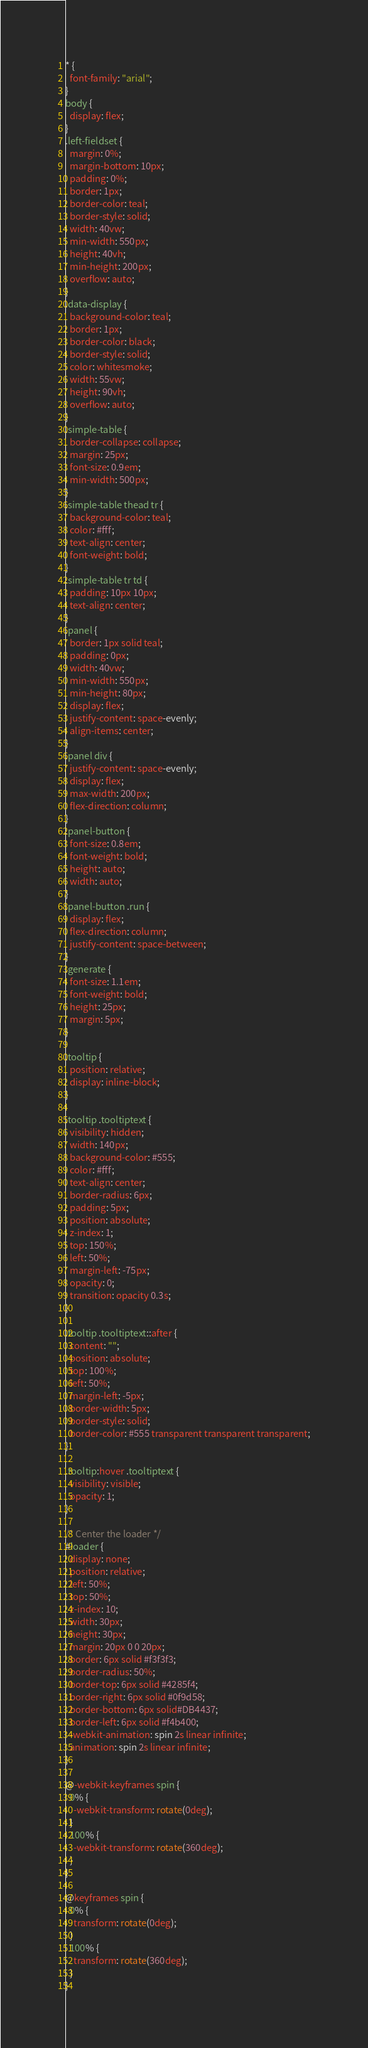<code> <loc_0><loc_0><loc_500><loc_500><_CSS_>* {
  font-family: "arial";
}
body {
  display: flex;
}
.left-fieldset {
  margin: 0%;
  margin-bottom: 10px;
  padding: 0%;
  border: 1px;
  border-color: teal;
  border-style: solid;
  width: 40vw;
  min-width: 550px;
  height: 40vh;
  min-height: 200px;
  overflow: auto;
}
.data-display {
  background-color: teal;
  border: 1px;
  border-color: black;
  border-style: solid;
  color: whitesmoke;
  width: 55vw;
  height: 90vh;
  overflow: auto;
}
.simple-table {
  border-collapse: collapse;
  margin: 25px;
  font-size: 0.9em;
  min-width: 500px;
}
.simple-table thead tr {
  background-color: teal;
  color: #fff;
  text-align: center;
  font-weight: bold;
}
.simple-table tr td {
  padding: 10px 10px;
  text-align: center;
}
.panel {
  border: 1px solid teal;
  padding: 0px;
  width: 40vw;
  min-width: 550px;
  min-height: 80px;
  display: flex;
  justify-content: space-evenly;
  align-items: center;
}
.panel div {
  justify-content: space-evenly;
  display: flex;
  max-width: 200px;
  flex-direction: column;
}
.panel-button {
  font-size: 0.8em;
  font-weight: bold;
  height: auto;
  width: auto;
}
.panel-button .run {
  display: flex;
  flex-direction: column;
  justify-content: space-between;
}
.generate {
  font-size: 1.1em;
  font-weight: bold;
  height: 25px;
  margin: 5px;
}

.tooltip {
  position: relative;
  display: inline-block;
}

.tooltip .tooltiptext {
  visibility: hidden;
  width: 140px;
  background-color: #555;
  color: #fff;
  text-align: center;
  border-radius: 6px;
  padding: 5px;
  position: absolute;
  z-index: 1;
  top: 150%;
  left: 50%;
  margin-left: -75px;
  opacity: 0;
  transition: opacity 0.3s;
}

.tooltip .tooltiptext::after {
  content: "";
  position: absolute;
  top: 100%;
  left: 50%;
  margin-left: -5px;
  border-width: 5px;
  border-style: solid;
  border-color: #555 transparent transparent transparent;
}

.tooltip:hover .tooltiptext {
  visibility: visible;
  opacity: 1;
}

/* Center the loader */
#loader {
  display: none;
  position: relative;
  left: 50%;
  top: 50%;
  z-index: 10;
  width: 30px;
  height: 30px;
  margin: 20px 0 0 20px;
  border: 6px solid #f3f3f3;
  border-radius: 50%;
  border-top: 6px solid #4285f4;
  border-right: 6px solid #0f9d58;
  border-bottom: 6px solid#DB4437;
  border-left: 6px solid #f4b400;
  -webkit-animation: spin 2s linear infinite;
  animation: spin 2s linear infinite;
}

@-webkit-keyframes spin {
  0% {
    -webkit-transform: rotate(0deg);
  }
  100% {
    -webkit-transform: rotate(360deg);
  }
}

@keyframes spin {
  0% {
    transform: rotate(0deg);
  }
  100% {
    transform: rotate(360deg);
  }
}
</code> 